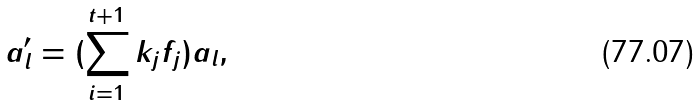<formula> <loc_0><loc_0><loc_500><loc_500>a ^ { \prime } _ { l } = ( \sum ^ { t + 1 } _ { i = 1 } k _ { j } f _ { j } ) a _ { l } ,</formula> 